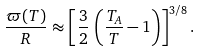Convert formula to latex. <formula><loc_0><loc_0><loc_500><loc_500>\frac { \varpi ( T ) } { R } \approx \left [ \frac { 3 } { 2 } \, \left ( \frac { T _ { A } } { T } - 1 \right ) \right ] ^ { 3 / 8 } .</formula> 